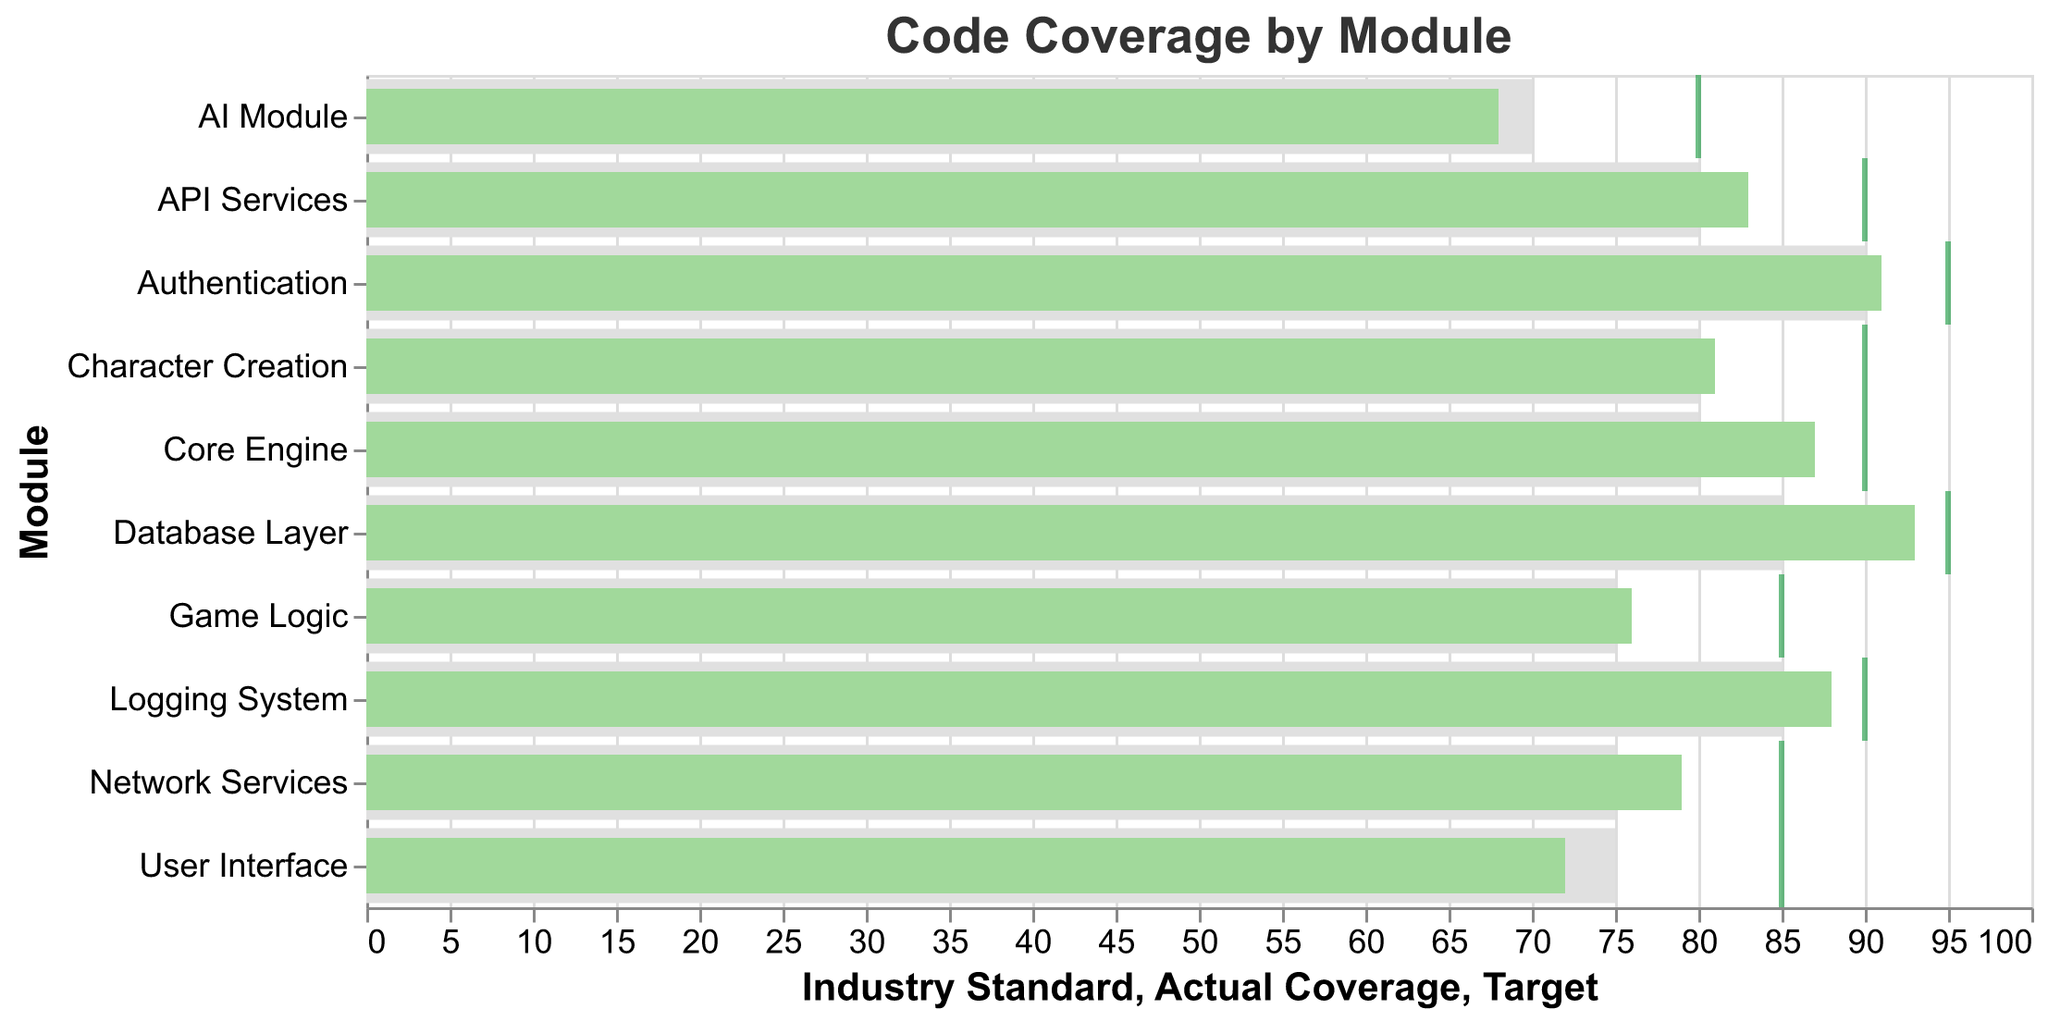What is the title of the figure? The title of the figure is located at the top and usually describes what the figure is about. In this case, it reads "Code Coverage by Module".
Answer: Code Coverage by Module Which module has the highest actual coverage? To find the module with the highest actual coverage, look for the tallest green bar in the chart, which indicates the actual coverage. The Database Layer module has the highest coverage at 93%.
Answer: Database Layer How does the AI Module's actual coverage compare to its target? Look for the AI Module in the chart and compare the height of the green bar (actual coverage) to the position of the tick mark (target). The AI Module's actual coverage is 68%, while its target is 80%.
Answer: 68% vs 80% Which modules have actual coverage below the industry standard? Find the modules where the green bar (actual coverage) does not reach the end of the gray bar representing the industry standard. The modules are User Interface, AI Module, and Network Services.
Answer: User Interface, AI Module, Network Services What is the difference between actual coverage and the target for the Core Engine module? For the Core Engine module, the actual coverage is 87% and the target is 90%. The difference is 90% - 87% = 3%.
Answer: 3% What proportion of modules meet or exceed the industry standard? Count the modules where the green bar meets or exceeds the length of the gray bar (industry standard). There are 10 modules in total, and 7 of them meet or exceed the standard. So, the proportion is 7/10.
Answer: 7/10 Which module has the largest gap between its actual coverage and industry standard? Identify the module with the largest difference between the actual coverage (green bar) and industry standard (gray bar). The User Interface module has the largest gap, with an actual coverage of 72% and an industry standard of 75%, resulting in a difference of 75% - 72% = 3%.
Answer: User Interface How many modules have an actual coverage above their targets? Count the number of modules where the green bar (actual coverage) exceeds the position of the tick mark (target). None of the modules have actual coverage above their targets.
Answer: 0 Among the modules that fail to meet their targets, which one is closest to reaching it? From the modules that fail to meet their targets, identify the one with the smallest difference between the actual coverage and its target. The Core Engine module is closest to its target with a difference of 3%.
Answer: Core Engine Is the Logging System's actual coverage above the industry standard? Look at the Logging System module. Compare the length of the green bar (88%) with that of the gray bar (85%) which represents the industry standard. Yes, it is above the industry standard.
Answer: Yes 